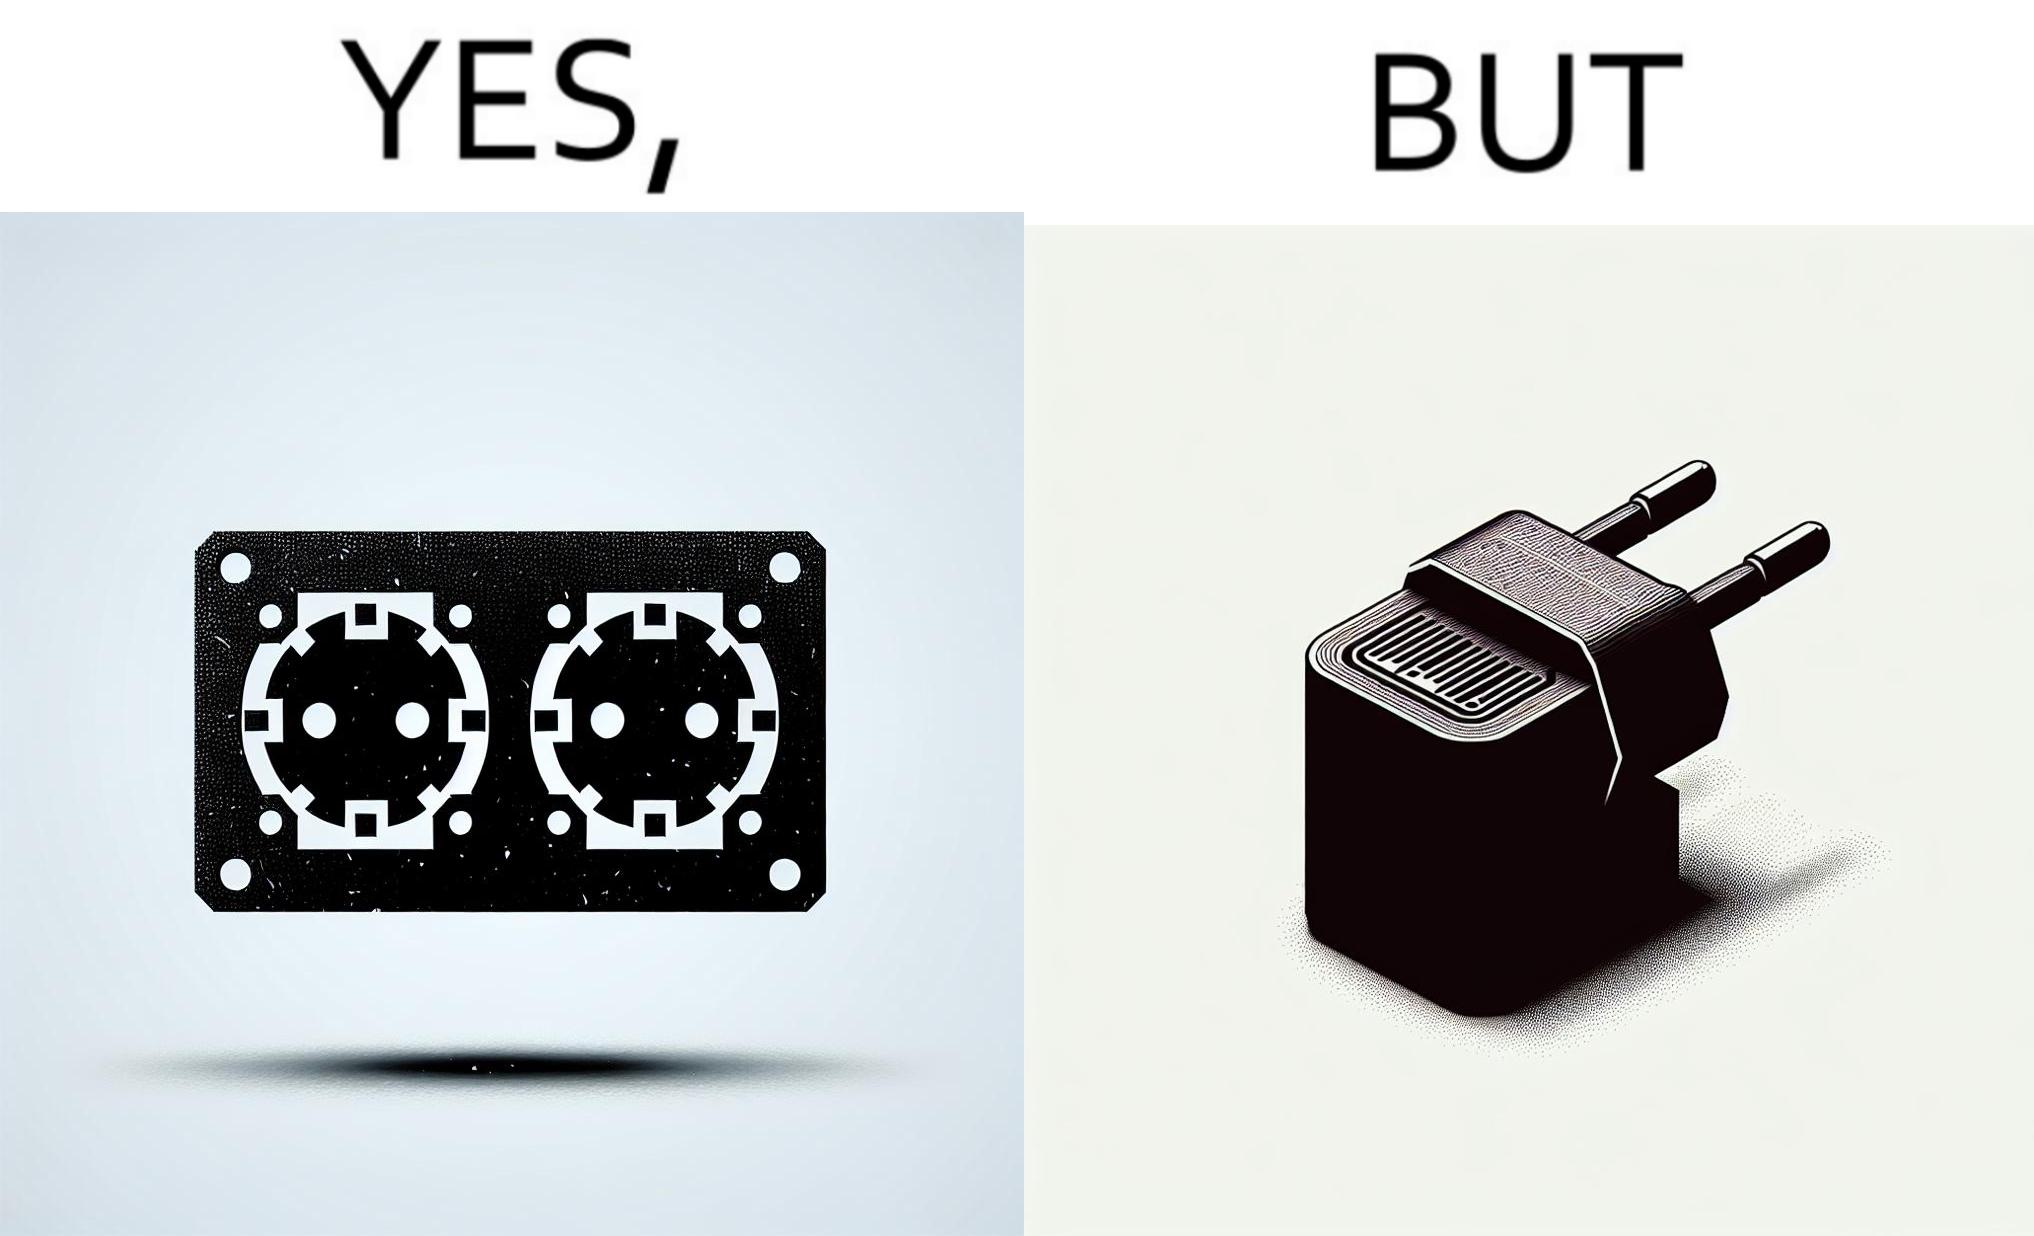Describe what you see in this image. The image is funny, as there are two electrical sockets side-by-side, but the adapter is shaped in such a way, that if two adapters are inserted into the two sockets, they will butt into each other, leading to inconvenience. 